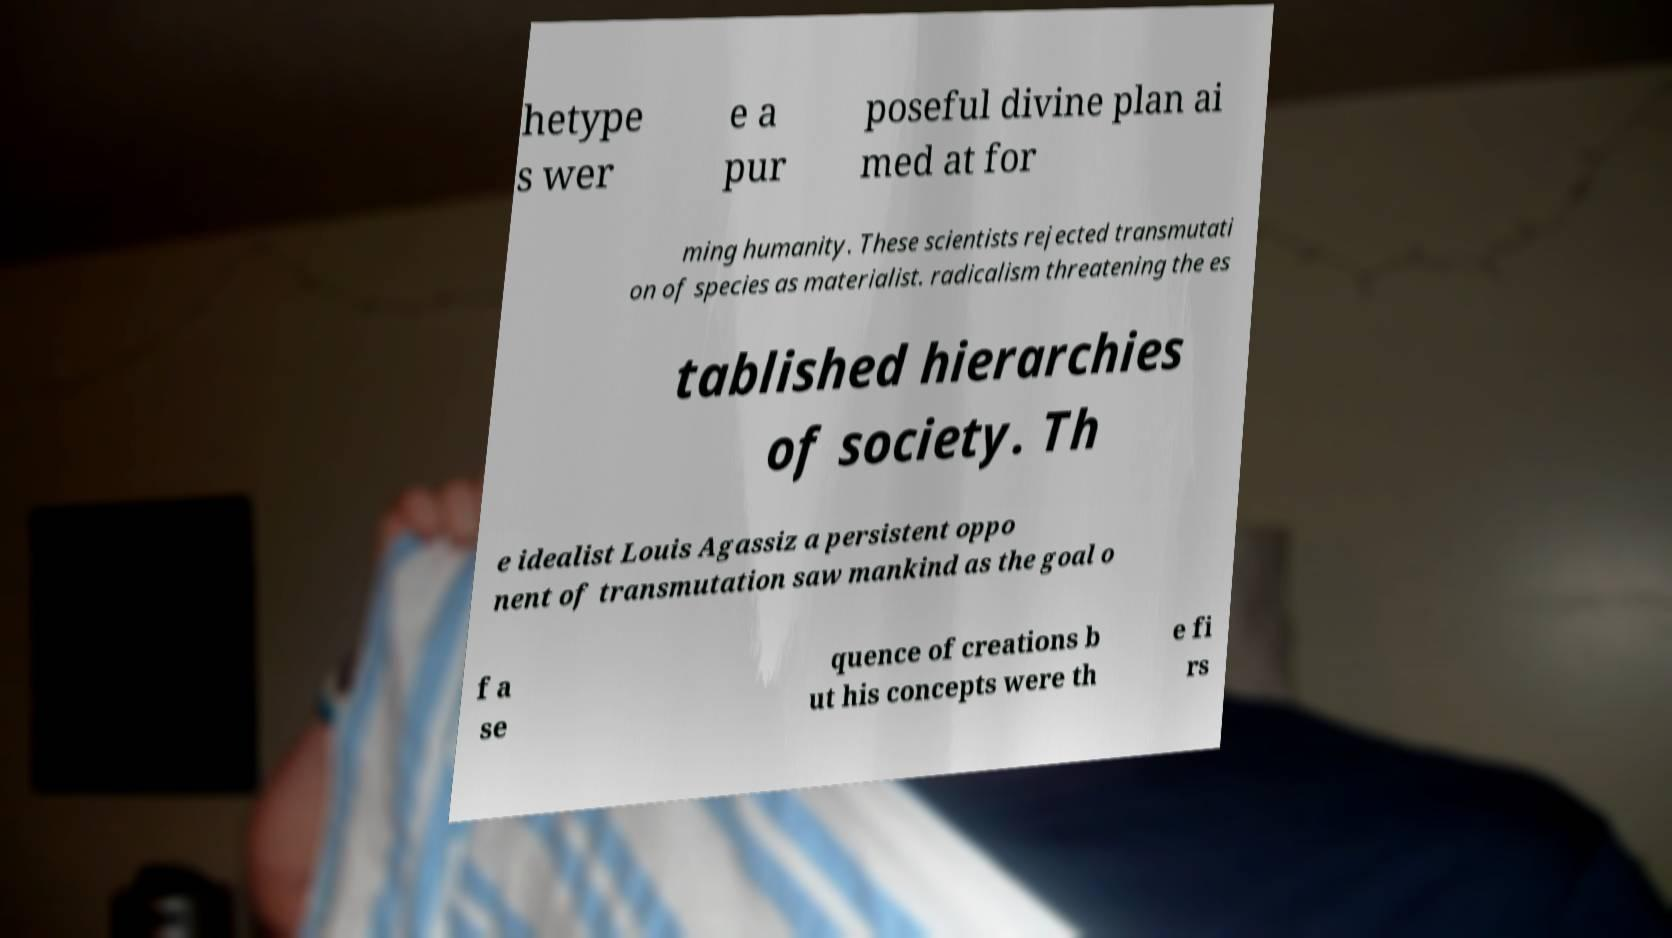Please identify and transcribe the text found in this image. hetype s wer e a pur poseful divine plan ai med at for ming humanity. These scientists rejected transmutati on of species as materialist. radicalism threatening the es tablished hierarchies of society. Th e idealist Louis Agassiz a persistent oppo nent of transmutation saw mankind as the goal o f a se quence of creations b ut his concepts were th e fi rs 